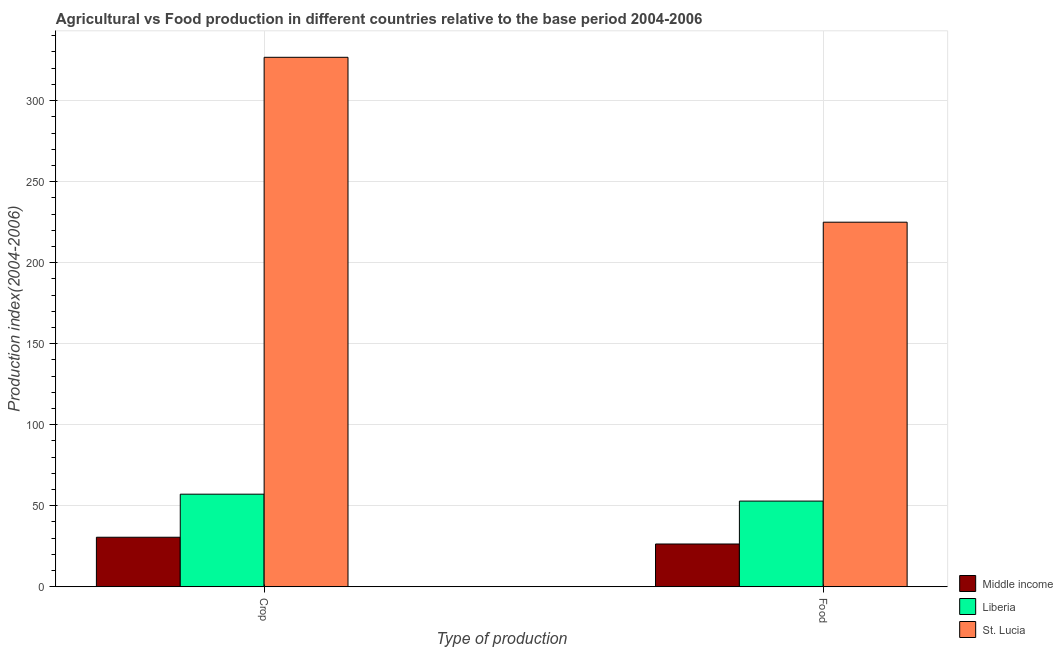How many different coloured bars are there?
Make the answer very short. 3. How many groups of bars are there?
Ensure brevity in your answer.  2. Are the number of bars per tick equal to the number of legend labels?
Offer a very short reply. Yes. Are the number of bars on each tick of the X-axis equal?
Offer a terse response. Yes. What is the label of the 2nd group of bars from the left?
Make the answer very short. Food. What is the crop production index in Middle income?
Provide a succinct answer. 30.55. Across all countries, what is the maximum crop production index?
Keep it short and to the point. 326.72. Across all countries, what is the minimum food production index?
Keep it short and to the point. 26.38. In which country was the crop production index maximum?
Your answer should be very brief. St. Lucia. In which country was the food production index minimum?
Offer a terse response. Middle income. What is the total food production index in the graph?
Offer a very short reply. 304.21. What is the difference between the food production index in Liberia and that in Middle income?
Your response must be concise. 26.49. What is the difference between the food production index in Middle income and the crop production index in St. Lucia?
Offer a terse response. -300.34. What is the average crop production index per country?
Give a very brief answer. 138.13. What is the difference between the crop production index and food production index in St. Lucia?
Keep it short and to the point. 101.76. In how many countries, is the food production index greater than 50 ?
Your response must be concise. 2. What is the ratio of the food production index in Liberia to that in St. Lucia?
Keep it short and to the point. 0.24. What does the 3rd bar from the right in Crop represents?
Give a very brief answer. Middle income. How many countries are there in the graph?
Provide a succinct answer. 3. Does the graph contain any zero values?
Your answer should be very brief. No. What is the title of the graph?
Your response must be concise. Agricultural vs Food production in different countries relative to the base period 2004-2006. What is the label or title of the X-axis?
Give a very brief answer. Type of production. What is the label or title of the Y-axis?
Offer a terse response. Production index(2004-2006). What is the Production index(2004-2006) in Middle income in Crop?
Offer a very short reply. 30.55. What is the Production index(2004-2006) in Liberia in Crop?
Your response must be concise. 57.13. What is the Production index(2004-2006) of St. Lucia in Crop?
Your response must be concise. 326.72. What is the Production index(2004-2006) in Middle income in Food?
Your response must be concise. 26.38. What is the Production index(2004-2006) in Liberia in Food?
Make the answer very short. 52.87. What is the Production index(2004-2006) of St. Lucia in Food?
Offer a terse response. 224.96. Across all Type of production, what is the maximum Production index(2004-2006) of Middle income?
Your answer should be compact. 30.55. Across all Type of production, what is the maximum Production index(2004-2006) in Liberia?
Provide a short and direct response. 57.13. Across all Type of production, what is the maximum Production index(2004-2006) in St. Lucia?
Ensure brevity in your answer.  326.72. Across all Type of production, what is the minimum Production index(2004-2006) of Middle income?
Make the answer very short. 26.38. Across all Type of production, what is the minimum Production index(2004-2006) of Liberia?
Your response must be concise. 52.87. Across all Type of production, what is the minimum Production index(2004-2006) of St. Lucia?
Ensure brevity in your answer.  224.96. What is the total Production index(2004-2006) of Middle income in the graph?
Offer a terse response. 56.93. What is the total Production index(2004-2006) of Liberia in the graph?
Ensure brevity in your answer.  110. What is the total Production index(2004-2006) of St. Lucia in the graph?
Offer a very short reply. 551.68. What is the difference between the Production index(2004-2006) of Middle income in Crop and that in Food?
Keep it short and to the point. 4.17. What is the difference between the Production index(2004-2006) of Liberia in Crop and that in Food?
Offer a very short reply. 4.26. What is the difference between the Production index(2004-2006) in St. Lucia in Crop and that in Food?
Offer a terse response. 101.76. What is the difference between the Production index(2004-2006) in Middle income in Crop and the Production index(2004-2006) in Liberia in Food?
Keep it short and to the point. -22.32. What is the difference between the Production index(2004-2006) in Middle income in Crop and the Production index(2004-2006) in St. Lucia in Food?
Ensure brevity in your answer.  -194.41. What is the difference between the Production index(2004-2006) in Liberia in Crop and the Production index(2004-2006) in St. Lucia in Food?
Make the answer very short. -167.83. What is the average Production index(2004-2006) of Middle income per Type of production?
Your answer should be very brief. 28.47. What is the average Production index(2004-2006) of St. Lucia per Type of production?
Your response must be concise. 275.84. What is the difference between the Production index(2004-2006) in Middle income and Production index(2004-2006) in Liberia in Crop?
Your answer should be compact. -26.58. What is the difference between the Production index(2004-2006) of Middle income and Production index(2004-2006) of St. Lucia in Crop?
Give a very brief answer. -296.17. What is the difference between the Production index(2004-2006) in Liberia and Production index(2004-2006) in St. Lucia in Crop?
Your answer should be very brief. -269.59. What is the difference between the Production index(2004-2006) of Middle income and Production index(2004-2006) of Liberia in Food?
Offer a terse response. -26.49. What is the difference between the Production index(2004-2006) of Middle income and Production index(2004-2006) of St. Lucia in Food?
Keep it short and to the point. -198.58. What is the difference between the Production index(2004-2006) in Liberia and Production index(2004-2006) in St. Lucia in Food?
Offer a terse response. -172.09. What is the ratio of the Production index(2004-2006) of Middle income in Crop to that in Food?
Your response must be concise. 1.16. What is the ratio of the Production index(2004-2006) in Liberia in Crop to that in Food?
Provide a succinct answer. 1.08. What is the ratio of the Production index(2004-2006) in St. Lucia in Crop to that in Food?
Ensure brevity in your answer.  1.45. What is the difference between the highest and the second highest Production index(2004-2006) in Middle income?
Give a very brief answer. 4.17. What is the difference between the highest and the second highest Production index(2004-2006) of Liberia?
Your answer should be very brief. 4.26. What is the difference between the highest and the second highest Production index(2004-2006) of St. Lucia?
Offer a terse response. 101.76. What is the difference between the highest and the lowest Production index(2004-2006) in Middle income?
Provide a short and direct response. 4.17. What is the difference between the highest and the lowest Production index(2004-2006) in Liberia?
Give a very brief answer. 4.26. What is the difference between the highest and the lowest Production index(2004-2006) of St. Lucia?
Ensure brevity in your answer.  101.76. 